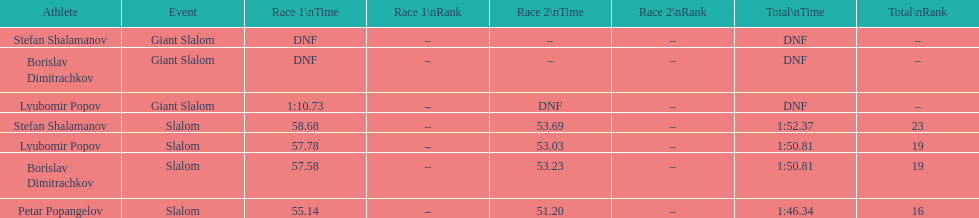Who was last in the slalom overall? Stefan Shalamanov. 